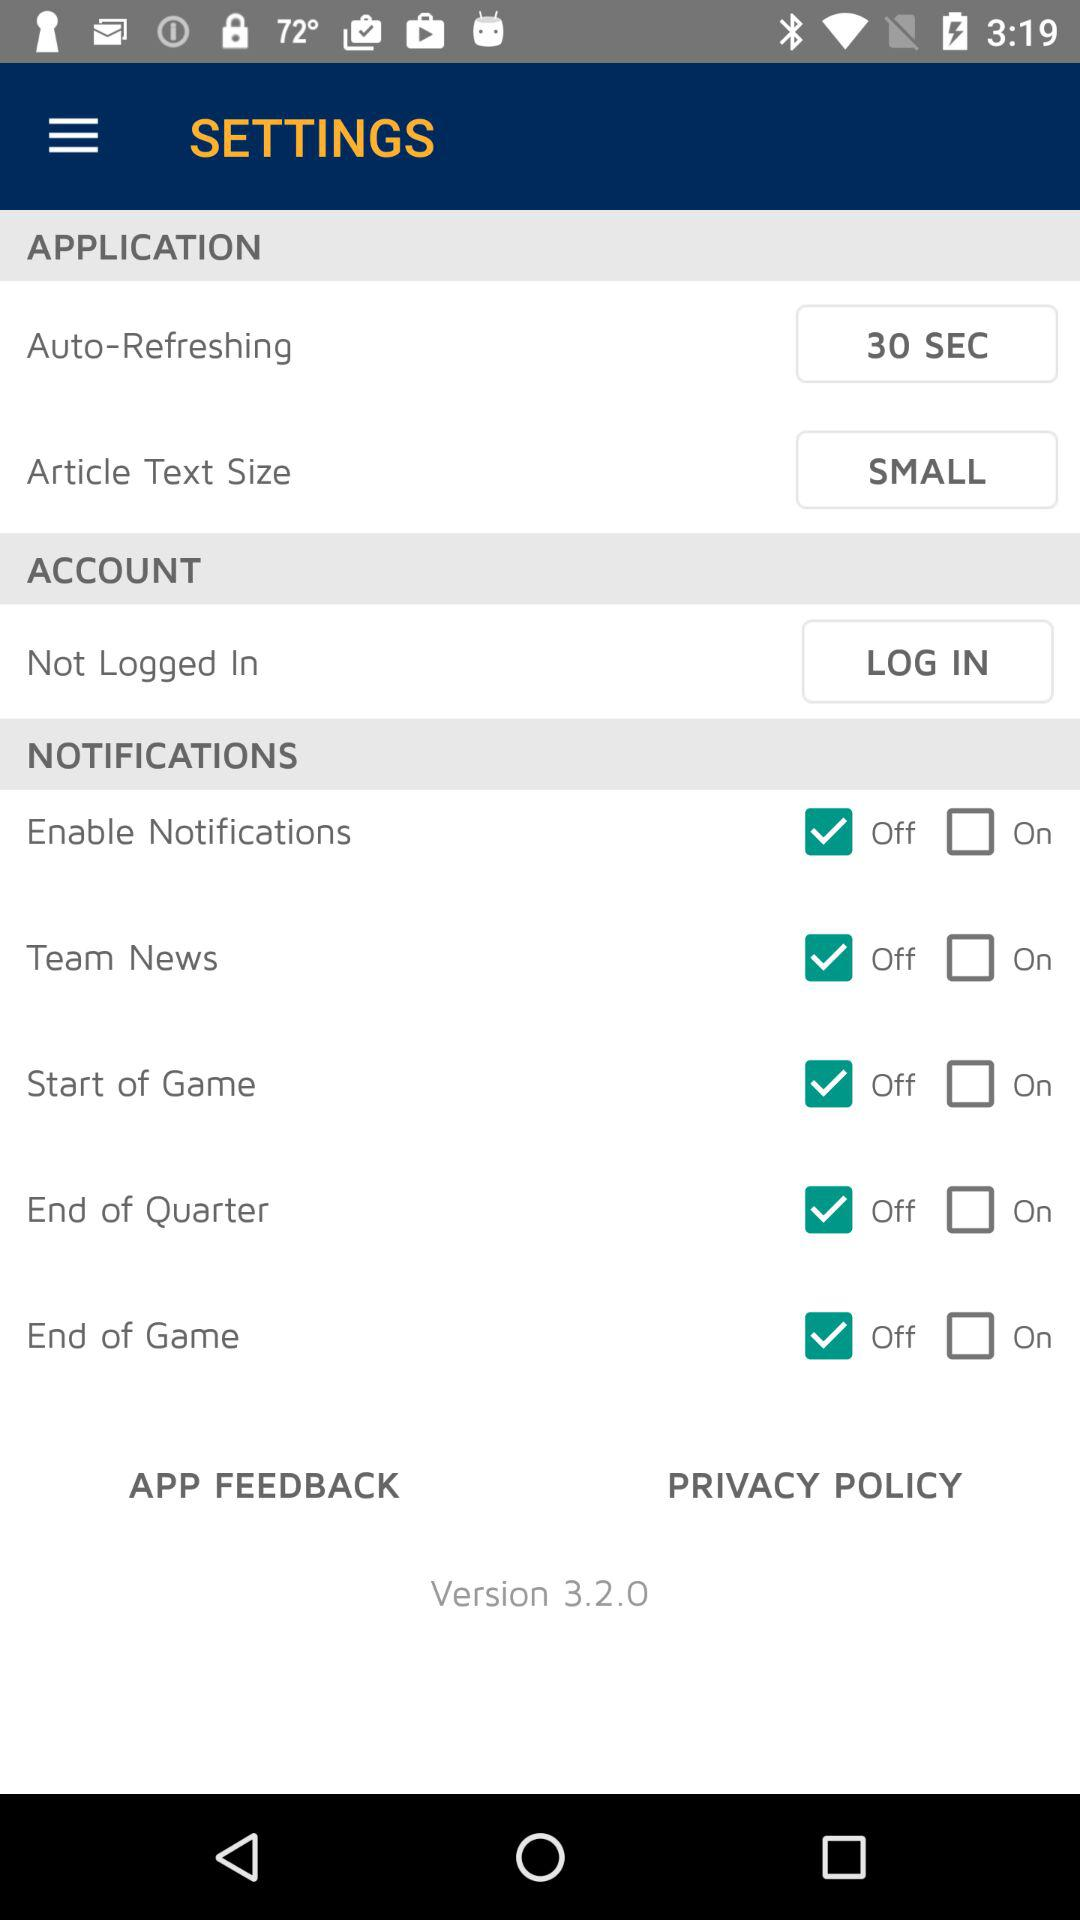What is the selected article text size? The selected article text size is "SMALL". 